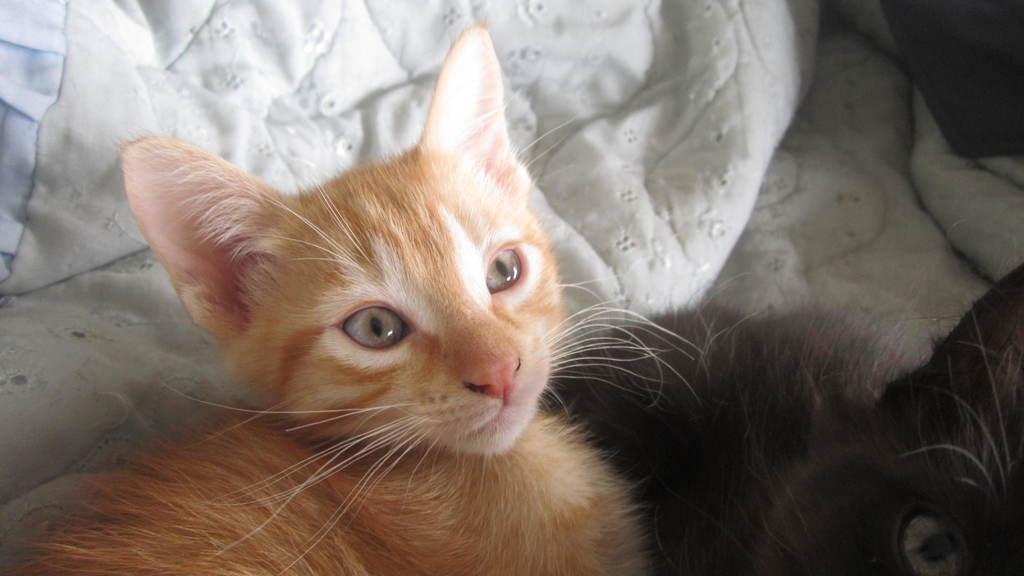What type of animals are in the image? There are cats in the image. What is covering the surface in the image? There is a bed sheet in the image. What can be observed about the lighting in the image? The background of the image is dark. What type of coal is being used to treat the wound on the cat in the image? There is no coal or wound present in the image; it features cats and a bed sheet. 